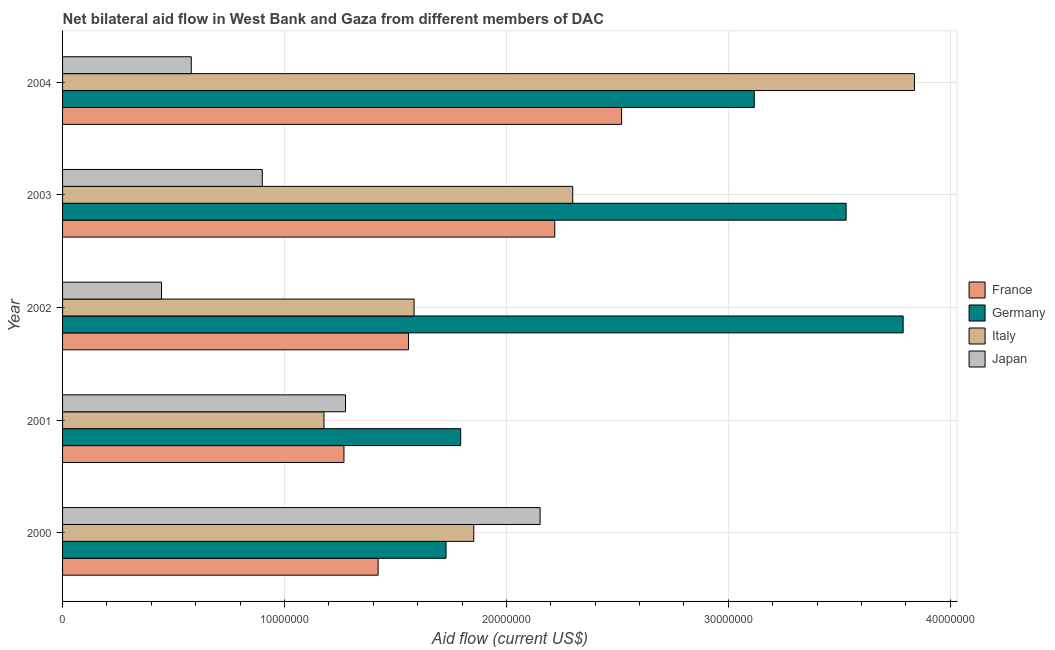How many groups of bars are there?
Provide a short and direct response. 5. How many bars are there on the 3rd tick from the top?
Your response must be concise. 4. What is the amount of aid given by italy in 2002?
Your answer should be very brief. 1.58e+07. Across all years, what is the maximum amount of aid given by germany?
Provide a short and direct response. 3.79e+07. Across all years, what is the minimum amount of aid given by italy?
Your answer should be compact. 1.18e+07. In which year was the amount of aid given by france minimum?
Provide a short and direct response. 2001. What is the total amount of aid given by germany in the graph?
Your response must be concise. 1.40e+08. What is the difference between the amount of aid given by japan in 2002 and that in 2003?
Provide a succinct answer. -4.54e+06. What is the difference between the amount of aid given by italy in 2000 and the amount of aid given by france in 2002?
Offer a very short reply. 2.94e+06. What is the average amount of aid given by japan per year?
Keep it short and to the point. 1.07e+07. In the year 2001, what is the difference between the amount of aid given by germany and amount of aid given by italy?
Give a very brief answer. 6.16e+06. What is the ratio of the amount of aid given by germany in 2001 to that in 2002?
Provide a succinct answer. 0.47. What is the difference between the highest and the second highest amount of aid given by germany?
Ensure brevity in your answer.  2.57e+06. What is the difference between the highest and the lowest amount of aid given by japan?
Ensure brevity in your answer.  1.71e+07. In how many years, is the amount of aid given by france greater than the average amount of aid given by france taken over all years?
Your response must be concise. 2. What does the 3rd bar from the bottom in 2003 represents?
Your answer should be compact. Italy. Is it the case that in every year, the sum of the amount of aid given by france and amount of aid given by germany is greater than the amount of aid given by italy?
Keep it short and to the point. Yes. How many bars are there?
Ensure brevity in your answer.  20. What is the difference between two consecutive major ticks on the X-axis?
Provide a succinct answer. 1.00e+07. Does the graph contain grids?
Make the answer very short. Yes. Where does the legend appear in the graph?
Give a very brief answer. Center right. How many legend labels are there?
Your answer should be compact. 4. How are the legend labels stacked?
Your response must be concise. Vertical. What is the title of the graph?
Your answer should be compact. Net bilateral aid flow in West Bank and Gaza from different members of DAC. Does "Tertiary schools" appear as one of the legend labels in the graph?
Provide a short and direct response. No. What is the label or title of the X-axis?
Make the answer very short. Aid flow (current US$). What is the Aid flow (current US$) of France in 2000?
Provide a succinct answer. 1.42e+07. What is the Aid flow (current US$) of Germany in 2000?
Your answer should be compact. 1.73e+07. What is the Aid flow (current US$) in Italy in 2000?
Offer a terse response. 1.85e+07. What is the Aid flow (current US$) of Japan in 2000?
Your response must be concise. 2.15e+07. What is the Aid flow (current US$) of France in 2001?
Provide a short and direct response. 1.27e+07. What is the Aid flow (current US$) of Germany in 2001?
Give a very brief answer. 1.79e+07. What is the Aid flow (current US$) of Italy in 2001?
Offer a very short reply. 1.18e+07. What is the Aid flow (current US$) of Japan in 2001?
Make the answer very short. 1.28e+07. What is the Aid flow (current US$) of France in 2002?
Provide a short and direct response. 1.56e+07. What is the Aid flow (current US$) in Germany in 2002?
Give a very brief answer. 3.79e+07. What is the Aid flow (current US$) in Italy in 2002?
Make the answer very short. 1.58e+07. What is the Aid flow (current US$) of Japan in 2002?
Offer a very short reply. 4.46e+06. What is the Aid flow (current US$) in France in 2003?
Make the answer very short. 2.22e+07. What is the Aid flow (current US$) in Germany in 2003?
Provide a short and direct response. 3.53e+07. What is the Aid flow (current US$) of Italy in 2003?
Provide a succinct answer. 2.30e+07. What is the Aid flow (current US$) in Japan in 2003?
Offer a very short reply. 9.00e+06. What is the Aid flow (current US$) of France in 2004?
Give a very brief answer. 2.52e+07. What is the Aid flow (current US$) of Germany in 2004?
Provide a short and direct response. 3.12e+07. What is the Aid flow (current US$) in Italy in 2004?
Your response must be concise. 3.84e+07. What is the Aid flow (current US$) of Japan in 2004?
Provide a short and direct response. 5.80e+06. Across all years, what is the maximum Aid flow (current US$) of France?
Your answer should be very brief. 2.52e+07. Across all years, what is the maximum Aid flow (current US$) in Germany?
Ensure brevity in your answer.  3.79e+07. Across all years, what is the maximum Aid flow (current US$) of Italy?
Ensure brevity in your answer.  3.84e+07. Across all years, what is the maximum Aid flow (current US$) in Japan?
Make the answer very short. 2.15e+07. Across all years, what is the minimum Aid flow (current US$) of France?
Your answer should be compact. 1.27e+07. Across all years, what is the minimum Aid flow (current US$) in Germany?
Offer a terse response. 1.73e+07. Across all years, what is the minimum Aid flow (current US$) in Italy?
Offer a terse response. 1.18e+07. Across all years, what is the minimum Aid flow (current US$) in Japan?
Your response must be concise. 4.46e+06. What is the total Aid flow (current US$) of France in the graph?
Offer a very short reply. 8.99e+07. What is the total Aid flow (current US$) of Germany in the graph?
Your response must be concise. 1.40e+08. What is the total Aid flow (current US$) in Italy in the graph?
Provide a short and direct response. 1.08e+08. What is the total Aid flow (current US$) in Japan in the graph?
Offer a very short reply. 5.35e+07. What is the difference between the Aid flow (current US$) of France in 2000 and that in 2001?
Your answer should be compact. 1.54e+06. What is the difference between the Aid flow (current US$) in Germany in 2000 and that in 2001?
Give a very brief answer. -6.60e+05. What is the difference between the Aid flow (current US$) in Italy in 2000 and that in 2001?
Offer a terse response. 6.75e+06. What is the difference between the Aid flow (current US$) in Japan in 2000 and that in 2001?
Offer a very short reply. 8.77e+06. What is the difference between the Aid flow (current US$) in France in 2000 and that in 2002?
Make the answer very short. -1.37e+06. What is the difference between the Aid flow (current US$) in Germany in 2000 and that in 2002?
Make the answer very short. -2.06e+07. What is the difference between the Aid flow (current US$) in Italy in 2000 and that in 2002?
Provide a short and direct response. 2.69e+06. What is the difference between the Aid flow (current US$) of Japan in 2000 and that in 2002?
Keep it short and to the point. 1.71e+07. What is the difference between the Aid flow (current US$) in France in 2000 and that in 2003?
Offer a very short reply. -7.96e+06. What is the difference between the Aid flow (current US$) of Germany in 2000 and that in 2003?
Make the answer very short. -1.80e+07. What is the difference between the Aid flow (current US$) of Italy in 2000 and that in 2003?
Give a very brief answer. -4.46e+06. What is the difference between the Aid flow (current US$) of Japan in 2000 and that in 2003?
Provide a short and direct response. 1.25e+07. What is the difference between the Aid flow (current US$) of France in 2000 and that in 2004?
Your answer should be compact. -1.10e+07. What is the difference between the Aid flow (current US$) of Germany in 2000 and that in 2004?
Keep it short and to the point. -1.39e+07. What is the difference between the Aid flow (current US$) in Italy in 2000 and that in 2004?
Your answer should be compact. -1.99e+07. What is the difference between the Aid flow (current US$) in Japan in 2000 and that in 2004?
Provide a short and direct response. 1.57e+07. What is the difference between the Aid flow (current US$) in France in 2001 and that in 2002?
Make the answer very short. -2.91e+06. What is the difference between the Aid flow (current US$) in Germany in 2001 and that in 2002?
Offer a very short reply. -1.99e+07. What is the difference between the Aid flow (current US$) of Italy in 2001 and that in 2002?
Your answer should be compact. -4.06e+06. What is the difference between the Aid flow (current US$) of Japan in 2001 and that in 2002?
Offer a very short reply. 8.29e+06. What is the difference between the Aid flow (current US$) in France in 2001 and that in 2003?
Your answer should be compact. -9.50e+06. What is the difference between the Aid flow (current US$) of Germany in 2001 and that in 2003?
Offer a very short reply. -1.74e+07. What is the difference between the Aid flow (current US$) in Italy in 2001 and that in 2003?
Provide a succinct answer. -1.12e+07. What is the difference between the Aid flow (current US$) of Japan in 2001 and that in 2003?
Your answer should be compact. 3.75e+06. What is the difference between the Aid flow (current US$) of France in 2001 and that in 2004?
Provide a succinct answer. -1.25e+07. What is the difference between the Aid flow (current US$) in Germany in 2001 and that in 2004?
Offer a terse response. -1.32e+07. What is the difference between the Aid flow (current US$) of Italy in 2001 and that in 2004?
Your answer should be compact. -2.66e+07. What is the difference between the Aid flow (current US$) in Japan in 2001 and that in 2004?
Make the answer very short. 6.95e+06. What is the difference between the Aid flow (current US$) in France in 2002 and that in 2003?
Keep it short and to the point. -6.59e+06. What is the difference between the Aid flow (current US$) in Germany in 2002 and that in 2003?
Offer a terse response. 2.57e+06. What is the difference between the Aid flow (current US$) of Italy in 2002 and that in 2003?
Give a very brief answer. -7.15e+06. What is the difference between the Aid flow (current US$) in Japan in 2002 and that in 2003?
Offer a terse response. -4.54e+06. What is the difference between the Aid flow (current US$) of France in 2002 and that in 2004?
Ensure brevity in your answer.  -9.60e+06. What is the difference between the Aid flow (current US$) in Germany in 2002 and that in 2004?
Give a very brief answer. 6.71e+06. What is the difference between the Aid flow (current US$) in Italy in 2002 and that in 2004?
Provide a succinct answer. -2.26e+07. What is the difference between the Aid flow (current US$) in Japan in 2002 and that in 2004?
Your response must be concise. -1.34e+06. What is the difference between the Aid flow (current US$) of France in 2003 and that in 2004?
Provide a succinct answer. -3.01e+06. What is the difference between the Aid flow (current US$) in Germany in 2003 and that in 2004?
Make the answer very short. 4.14e+06. What is the difference between the Aid flow (current US$) of Italy in 2003 and that in 2004?
Make the answer very short. -1.54e+07. What is the difference between the Aid flow (current US$) in Japan in 2003 and that in 2004?
Keep it short and to the point. 3.20e+06. What is the difference between the Aid flow (current US$) of France in 2000 and the Aid flow (current US$) of Germany in 2001?
Keep it short and to the point. -3.72e+06. What is the difference between the Aid flow (current US$) in France in 2000 and the Aid flow (current US$) in Italy in 2001?
Offer a terse response. 2.44e+06. What is the difference between the Aid flow (current US$) of France in 2000 and the Aid flow (current US$) of Japan in 2001?
Provide a succinct answer. 1.47e+06. What is the difference between the Aid flow (current US$) in Germany in 2000 and the Aid flow (current US$) in Italy in 2001?
Offer a very short reply. 5.50e+06. What is the difference between the Aid flow (current US$) of Germany in 2000 and the Aid flow (current US$) of Japan in 2001?
Your answer should be compact. 4.53e+06. What is the difference between the Aid flow (current US$) of Italy in 2000 and the Aid flow (current US$) of Japan in 2001?
Provide a succinct answer. 5.78e+06. What is the difference between the Aid flow (current US$) in France in 2000 and the Aid flow (current US$) in Germany in 2002?
Give a very brief answer. -2.37e+07. What is the difference between the Aid flow (current US$) in France in 2000 and the Aid flow (current US$) in Italy in 2002?
Give a very brief answer. -1.62e+06. What is the difference between the Aid flow (current US$) in France in 2000 and the Aid flow (current US$) in Japan in 2002?
Offer a very short reply. 9.76e+06. What is the difference between the Aid flow (current US$) in Germany in 2000 and the Aid flow (current US$) in Italy in 2002?
Keep it short and to the point. 1.44e+06. What is the difference between the Aid flow (current US$) in Germany in 2000 and the Aid flow (current US$) in Japan in 2002?
Your response must be concise. 1.28e+07. What is the difference between the Aid flow (current US$) in Italy in 2000 and the Aid flow (current US$) in Japan in 2002?
Your response must be concise. 1.41e+07. What is the difference between the Aid flow (current US$) in France in 2000 and the Aid flow (current US$) in Germany in 2003?
Ensure brevity in your answer.  -2.11e+07. What is the difference between the Aid flow (current US$) of France in 2000 and the Aid flow (current US$) of Italy in 2003?
Make the answer very short. -8.77e+06. What is the difference between the Aid flow (current US$) in France in 2000 and the Aid flow (current US$) in Japan in 2003?
Provide a short and direct response. 5.22e+06. What is the difference between the Aid flow (current US$) in Germany in 2000 and the Aid flow (current US$) in Italy in 2003?
Offer a terse response. -5.71e+06. What is the difference between the Aid flow (current US$) in Germany in 2000 and the Aid flow (current US$) in Japan in 2003?
Keep it short and to the point. 8.28e+06. What is the difference between the Aid flow (current US$) in Italy in 2000 and the Aid flow (current US$) in Japan in 2003?
Offer a terse response. 9.53e+06. What is the difference between the Aid flow (current US$) of France in 2000 and the Aid flow (current US$) of Germany in 2004?
Make the answer very short. -1.70e+07. What is the difference between the Aid flow (current US$) of France in 2000 and the Aid flow (current US$) of Italy in 2004?
Offer a very short reply. -2.42e+07. What is the difference between the Aid flow (current US$) in France in 2000 and the Aid flow (current US$) in Japan in 2004?
Provide a succinct answer. 8.42e+06. What is the difference between the Aid flow (current US$) of Germany in 2000 and the Aid flow (current US$) of Italy in 2004?
Provide a short and direct response. -2.11e+07. What is the difference between the Aid flow (current US$) of Germany in 2000 and the Aid flow (current US$) of Japan in 2004?
Your answer should be very brief. 1.15e+07. What is the difference between the Aid flow (current US$) in Italy in 2000 and the Aid flow (current US$) in Japan in 2004?
Give a very brief answer. 1.27e+07. What is the difference between the Aid flow (current US$) in France in 2001 and the Aid flow (current US$) in Germany in 2002?
Give a very brief answer. -2.52e+07. What is the difference between the Aid flow (current US$) in France in 2001 and the Aid flow (current US$) in Italy in 2002?
Your response must be concise. -3.16e+06. What is the difference between the Aid flow (current US$) in France in 2001 and the Aid flow (current US$) in Japan in 2002?
Provide a succinct answer. 8.22e+06. What is the difference between the Aid flow (current US$) of Germany in 2001 and the Aid flow (current US$) of Italy in 2002?
Provide a succinct answer. 2.10e+06. What is the difference between the Aid flow (current US$) in Germany in 2001 and the Aid flow (current US$) in Japan in 2002?
Keep it short and to the point. 1.35e+07. What is the difference between the Aid flow (current US$) in Italy in 2001 and the Aid flow (current US$) in Japan in 2002?
Your answer should be compact. 7.32e+06. What is the difference between the Aid flow (current US$) in France in 2001 and the Aid flow (current US$) in Germany in 2003?
Provide a succinct answer. -2.26e+07. What is the difference between the Aid flow (current US$) in France in 2001 and the Aid flow (current US$) in Italy in 2003?
Ensure brevity in your answer.  -1.03e+07. What is the difference between the Aid flow (current US$) in France in 2001 and the Aid flow (current US$) in Japan in 2003?
Offer a terse response. 3.68e+06. What is the difference between the Aid flow (current US$) in Germany in 2001 and the Aid flow (current US$) in Italy in 2003?
Provide a short and direct response. -5.05e+06. What is the difference between the Aid flow (current US$) of Germany in 2001 and the Aid flow (current US$) of Japan in 2003?
Keep it short and to the point. 8.94e+06. What is the difference between the Aid flow (current US$) in Italy in 2001 and the Aid flow (current US$) in Japan in 2003?
Keep it short and to the point. 2.78e+06. What is the difference between the Aid flow (current US$) of France in 2001 and the Aid flow (current US$) of Germany in 2004?
Ensure brevity in your answer.  -1.85e+07. What is the difference between the Aid flow (current US$) of France in 2001 and the Aid flow (current US$) of Italy in 2004?
Your answer should be compact. -2.57e+07. What is the difference between the Aid flow (current US$) of France in 2001 and the Aid flow (current US$) of Japan in 2004?
Provide a short and direct response. 6.88e+06. What is the difference between the Aid flow (current US$) of Germany in 2001 and the Aid flow (current US$) of Italy in 2004?
Your answer should be compact. -2.04e+07. What is the difference between the Aid flow (current US$) in Germany in 2001 and the Aid flow (current US$) in Japan in 2004?
Provide a short and direct response. 1.21e+07. What is the difference between the Aid flow (current US$) in Italy in 2001 and the Aid flow (current US$) in Japan in 2004?
Your answer should be compact. 5.98e+06. What is the difference between the Aid flow (current US$) of France in 2002 and the Aid flow (current US$) of Germany in 2003?
Provide a succinct answer. -1.97e+07. What is the difference between the Aid flow (current US$) in France in 2002 and the Aid flow (current US$) in Italy in 2003?
Your answer should be very brief. -7.40e+06. What is the difference between the Aid flow (current US$) of France in 2002 and the Aid flow (current US$) of Japan in 2003?
Provide a short and direct response. 6.59e+06. What is the difference between the Aid flow (current US$) of Germany in 2002 and the Aid flow (current US$) of Italy in 2003?
Your answer should be very brief. 1.49e+07. What is the difference between the Aid flow (current US$) of Germany in 2002 and the Aid flow (current US$) of Japan in 2003?
Provide a short and direct response. 2.89e+07. What is the difference between the Aid flow (current US$) in Italy in 2002 and the Aid flow (current US$) in Japan in 2003?
Your response must be concise. 6.84e+06. What is the difference between the Aid flow (current US$) in France in 2002 and the Aid flow (current US$) in Germany in 2004?
Make the answer very short. -1.56e+07. What is the difference between the Aid flow (current US$) of France in 2002 and the Aid flow (current US$) of Italy in 2004?
Your answer should be compact. -2.28e+07. What is the difference between the Aid flow (current US$) in France in 2002 and the Aid flow (current US$) in Japan in 2004?
Keep it short and to the point. 9.79e+06. What is the difference between the Aid flow (current US$) of Germany in 2002 and the Aid flow (current US$) of Italy in 2004?
Provide a succinct answer. -5.10e+05. What is the difference between the Aid flow (current US$) in Germany in 2002 and the Aid flow (current US$) in Japan in 2004?
Make the answer very short. 3.21e+07. What is the difference between the Aid flow (current US$) of Italy in 2002 and the Aid flow (current US$) of Japan in 2004?
Ensure brevity in your answer.  1.00e+07. What is the difference between the Aid flow (current US$) of France in 2003 and the Aid flow (current US$) of Germany in 2004?
Offer a terse response. -8.99e+06. What is the difference between the Aid flow (current US$) of France in 2003 and the Aid flow (current US$) of Italy in 2004?
Make the answer very short. -1.62e+07. What is the difference between the Aid flow (current US$) in France in 2003 and the Aid flow (current US$) in Japan in 2004?
Provide a short and direct response. 1.64e+07. What is the difference between the Aid flow (current US$) of Germany in 2003 and the Aid flow (current US$) of Italy in 2004?
Make the answer very short. -3.08e+06. What is the difference between the Aid flow (current US$) of Germany in 2003 and the Aid flow (current US$) of Japan in 2004?
Your answer should be very brief. 2.95e+07. What is the difference between the Aid flow (current US$) in Italy in 2003 and the Aid flow (current US$) in Japan in 2004?
Keep it short and to the point. 1.72e+07. What is the average Aid flow (current US$) in France per year?
Give a very brief answer. 1.80e+07. What is the average Aid flow (current US$) in Germany per year?
Provide a short and direct response. 2.79e+07. What is the average Aid flow (current US$) in Italy per year?
Your answer should be very brief. 2.15e+07. What is the average Aid flow (current US$) in Japan per year?
Ensure brevity in your answer.  1.07e+07. In the year 2000, what is the difference between the Aid flow (current US$) of France and Aid flow (current US$) of Germany?
Your response must be concise. -3.06e+06. In the year 2000, what is the difference between the Aid flow (current US$) of France and Aid flow (current US$) of Italy?
Provide a succinct answer. -4.31e+06. In the year 2000, what is the difference between the Aid flow (current US$) in France and Aid flow (current US$) in Japan?
Offer a terse response. -7.30e+06. In the year 2000, what is the difference between the Aid flow (current US$) in Germany and Aid flow (current US$) in Italy?
Your answer should be compact. -1.25e+06. In the year 2000, what is the difference between the Aid flow (current US$) in Germany and Aid flow (current US$) in Japan?
Offer a terse response. -4.24e+06. In the year 2000, what is the difference between the Aid flow (current US$) in Italy and Aid flow (current US$) in Japan?
Your answer should be compact. -2.99e+06. In the year 2001, what is the difference between the Aid flow (current US$) of France and Aid flow (current US$) of Germany?
Ensure brevity in your answer.  -5.26e+06. In the year 2001, what is the difference between the Aid flow (current US$) in France and Aid flow (current US$) in Italy?
Give a very brief answer. 9.00e+05. In the year 2001, what is the difference between the Aid flow (current US$) in Germany and Aid flow (current US$) in Italy?
Keep it short and to the point. 6.16e+06. In the year 2001, what is the difference between the Aid flow (current US$) in Germany and Aid flow (current US$) in Japan?
Keep it short and to the point. 5.19e+06. In the year 2001, what is the difference between the Aid flow (current US$) of Italy and Aid flow (current US$) of Japan?
Provide a short and direct response. -9.70e+05. In the year 2002, what is the difference between the Aid flow (current US$) of France and Aid flow (current US$) of Germany?
Keep it short and to the point. -2.23e+07. In the year 2002, what is the difference between the Aid flow (current US$) in France and Aid flow (current US$) in Japan?
Your response must be concise. 1.11e+07. In the year 2002, what is the difference between the Aid flow (current US$) in Germany and Aid flow (current US$) in Italy?
Your answer should be very brief. 2.20e+07. In the year 2002, what is the difference between the Aid flow (current US$) in Germany and Aid flow (current US$) in Japan?
Provide a succinct answer. 3.34e+07. In the year 2002, what is the difference between the Aid flow (current US$) in Italy and Aid flow (current US$) in Japan?
Your answer should be compact. 1.14e+07. In the year 2003, what is the difference between the Aid flow (current US$) in France and Aid flow (current US$) in Germany?
Keep it short and to the point. -1.31e+07. In the year 2003, what is the difference between the Aid flow (current US$) in France and Aid flow (current US$) in Italy?
Your response must be concise. -8.10e+05. In the year 2003, what is the difference between the Aid flow (current US$) of France and Aid flow (current US$) of Japan?
Provide a short and direct response. 1.32e+07. In the year 2003, what is the difference between the Aid flow (current US$) in Germany and Aid flow (current US$) in Italy?
Your response must be concise. 1.23e+07. In the year 2003, what is the difference between the Aid flow (current US$) of Germany and Aid flow (current US$) of Japan?
Provide a succinct answer. 2.63e+07. In the year 2003, what is the difference between the Aid flow (current US$) of Italy and Aid flow (current US$) of Japan?
Offer a very short reply. 1.40e+07. In the year 2004, what is the difference between the Aid flow (current US$) in France and Aid flow (current US$) in Germany?
Keep it short and to the point. -5.98e+06. In the year 2004, what is the difference between the Aid flow (current US$) of France and Aid flow (current US$) of Italy?
Give a very brief answer. -1.32e+07. In the year 2004, what is the difference between the Aid flow (current US$) of France and Aid flow (current US$) of Japan?
Your answer should be compact. 1.94e+07. In the year 2004, what is the difference between the Aid flow (current US$) of Germany and Aid flow (current US$) of Italy?
Keep it short and to the point. -7.22e+06. In the year 2004, what is the difference between the Aid flow (current US$) in Germany and Aid flow (current US$) in Japan?
Your response must be concise. 2.54e+07. In the year 2004, what is the difference between the Aid flow (current US$) of Italy and Aid flow (current US$) of Japan?
Give a very brief answer. 3.26e+07. What is the ratio of the Aid flow (current US$) of France in 2000 to that in 2001?
Give a very brief answer. 1.12. What is the ratio of the Aid flow (current US$) of Germany in 2000 to that in 2001?
Offer a terse response. 0.96. What is the ratio of the Aid flow (current US$) of Italy in 2000 to that in 2001?
Offer a terse response. 1.57. What is the ratio of the Aid flow (current US$) in Japan in 2000 to that in 2001?
Offer a very short reply. 1.69. What is the ratio of the Aid flow (current US$) in France in 2000 to that in 2002?
Ensure brevity in your answer.  0.91. What is the ratio of the Aid flow (current US$) in Germany in 2000 to that in 2002?
Your response must be concise. 0.46. What is the ratio of the Aid flow (current US$) in Italy in 2000 to that in 2002?
Your answer should be compact. 1.17. What is the ratio of the Aid flow (current US$) of Japan in 2000 to that in 2002?
Offer a terse response. 4.83. What is the ratio of the Aid flow (current US$) in France in 2000 to that in 2003?
Your response must be concise. 0.64. What is the ratio of the Aid flow (current US$) in Germany in 2000 to that in 2003?
Ensure brevity in your answer.  0.49. What is the ratio of the Aid flow (current US$) of Italy in 2000 to that in 2003?
Make the answer very short. 0.81. What is the ratio of the Aid flow (current US$) of Japan in 2000 to that in 2003?
Your answer should be compact. 2.39. What is the ratio of the Aid flow (current US$) in France in 2000 to that in 2004?
Make the answer very short. 0.56. What is the ratio of the Aid flow (current US$) of Germany in 2000 to that in 2004?
Your answer should be compact. 0.55. What is the ratio of the Aid flow (current US$) of Italy in 2000 to that in 2004?
Your answer should be compact. 0.48. What is the ratio of the Aid flow (current US$) of Japan in 2000 to that in 2004?
Your response must be concise. 3.71. What is the ratio of the Aid flow (current US$) in France in 2001 to that in 2002?
Make the answer very short. 0.81. What is the ratio of the Aid flow (current US$) of Germany in 2001 to that in 2002?
Keep it short and to the point. 0.47. What is the ratio of the Aid flow (current US$) of Italy in 2001 to that in 2002?
Your answer should be very brief. 0.74. What is the ratio of the Aid flow (current US$) of Japan in 2001 to that in 2002?
Offer a terse response. 2.86. What is the ratio of the Aid flow (current US$) in France in 2001 to that in 2003?
Keep it short and to the point. 0.57. What is the ratio of the Aid flow (current US$) in Germany in 2001 to that in 2003?
Give a very brief answer. 0.51. What is the ratio of the Aid flow (current US$) of Italy in 2001 to that in 2003?
Your answer should be compact. 0.51. What is the ratio of the Aid flow (current US$) of Japan in 2001 to that in 2003?
Provide a succinct answer. 1.42. What is the ratio of the Aid flow (current US$) in France in 2001 to that in 2004?
Offer a terse response. 0.5. What is the ratio of the Aid flow (current US$) of Germany in 2001 to that in 2004?
Your response must be concise. 0.58. What is the ratio of the Aid flow (current US$) of Italy in 2001 to that in 2004?
Provide a short and direct response. 0.31. What is the ratio of the Aid flow (current US$) of Japan in 2001 to that in 2004?
Your response must be concise. 2.2. What is the ratio of the Aid flow (current US$) in France in 2002 to that in 2003?
Provide a succinct answer. 0.7. What is the ratio of the Aid flow (current US$) of Germany in 2002 to that in 2003?
Make the answer very short. 1.07. What is the ratio of the Aid flow (current US$) of Italy in 2002 to that in 2003?
Offer a terse response. 0.69. What is the ratio of the Aid flow (current US$) of Japan in 2002 to that in 2003?
Keep it short and to the point. 0.5. What is the ratio of the Aid flow (current US$) in France in 2002 to that in 2004?
Provide a short and direct response. 0.62. What is the ratio of the Aid flow (current US$) in Germany in 2002 to that in 2004?
Provide a short and direct response. 1.22. What is the ratio of the Aid flow (current US$) in Italy in 2002 to that in 2004?
Make the answer very short. 0.41. What is the ratio of the Aid flow (current US$) of Japan in 2002 to that in 2004?
Offer a terse response. 0.77. What is the ratio of the Aid flow (current US$) of France in 2003 to that in 2004?
Provide a short and direct response. 0.88. What is the ratio of the Aid flow (current US$) in Germany in 2003 to that in 2004?
Your answer should be very brief. 1.13. What is the ratio of the Aid flow (current US$) in Italy in 2003 to that in 2004?
Give a very brief answer. 0.6. What is the ratio of the Aid flow (current US$) in Japan in 2003 to that in 2004?
Give a very brief answer. 1.55. What is the difference between the highest and the second highest Aid flow (current US$) in France?
Ensure brevity in your answer.  3.01e+06. What is the difference between the highest and the second highest Aid flow (current US$) of Germany?
Your answer should be very brief. 2.57e+06. What is the difference between the highest and the second highest Aid flow (current US$) in Italy?
Offer a terse response. 1.54e+07. What is the difference between the highest and the second highest Aid flow (current US$) of Japan?
Your response must be concise. 8.77e+06. What is the difference between the highest and the lowest Aid flow (current US$) of France?
Keep it short and to the point. 1.25e+07. What is the difference between the highest and the lowest Aid flow (current US$) of Germany?
Your answer should be very brief. 2.06e+07. What is the difference between the highest and the lowest Aid flow (current US$) in Italy?
Your response must be concise. 2.66e+07. What is the difference between the highest and the lowest Aid flow (current US$) of Japan?
Offer a terse response. 1.71e+07. 